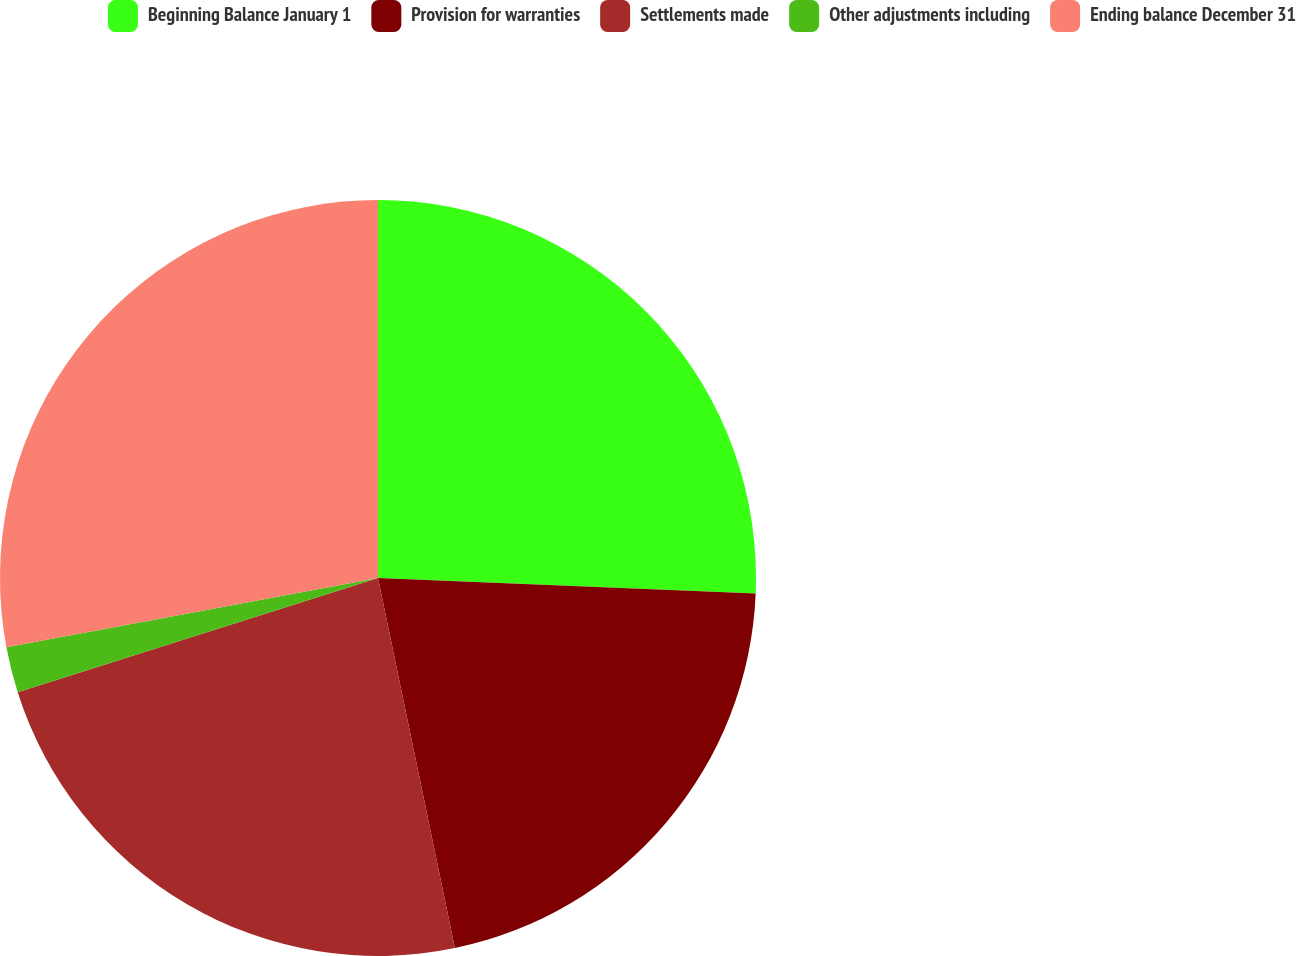Convert chart to OTSL. <chart><loc_0><loc_0><loc_500><loc_500><pie_chart><fcel>Beginning Balance January 1<fcel>Provision for warranties<fcel>Settlements made<fcel>Other adjustments including<fcel>Ending balance December 31<nl><fcel>25.65%<fcel>21.09%<fcel>23.37%<fcel>1.96%<fcel>27.93%<nl></chart> 